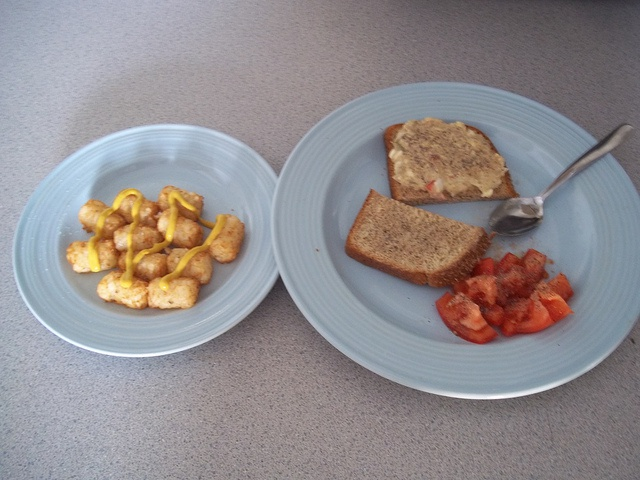Describe the objects in this image and their specific colors. I can see dining table in darkgray and gray tones, sandwich in darkgray, gray, tan, and brown tones, and spoon in darkgray, gray, and black tones in this image. 